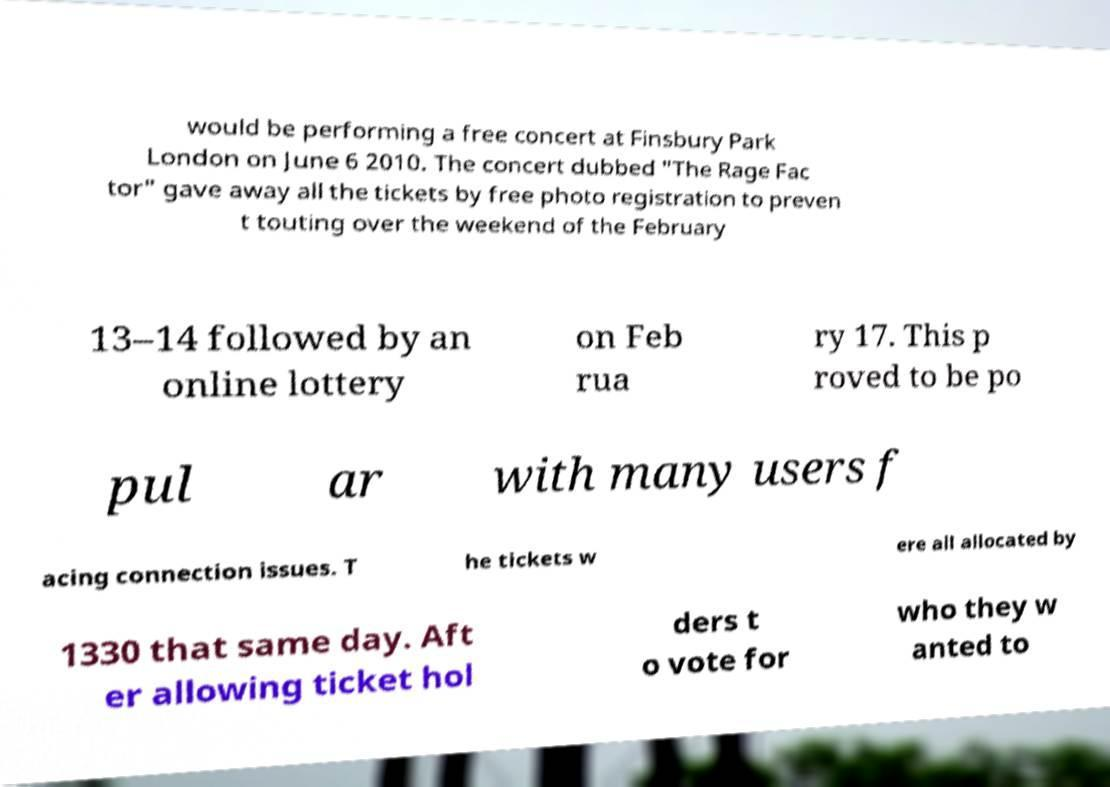Could you assist in decoding the text presented in this image and type it out clearly? would be performing a free concert at Finsbury Park London on June 6 2010. The concert dubbed "The Rage Fac tor" gave away all the tickets by free photo registration to preven t touting over the weekend of the February 13–14 followed by an online lottery on Feb rua ry 17. This p roved to be po pul ar with many users f acing connection issues. T he tickets w ere all allocated by 1330 that same day. Aft er allowing ticket hol ders t o vote for who they w anted to 